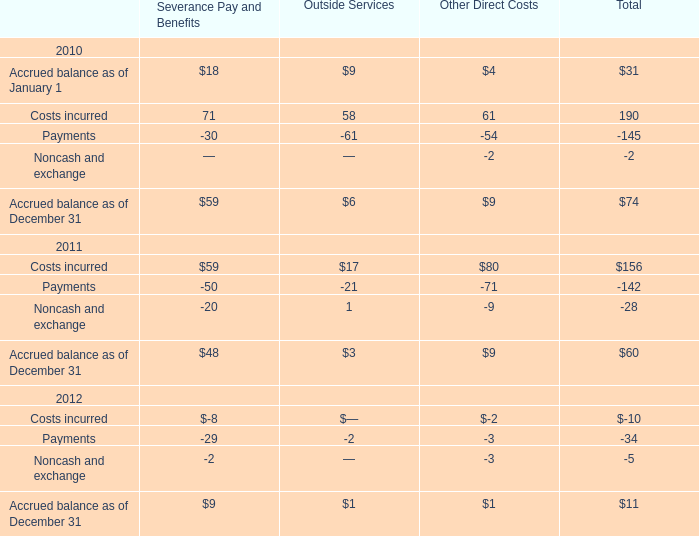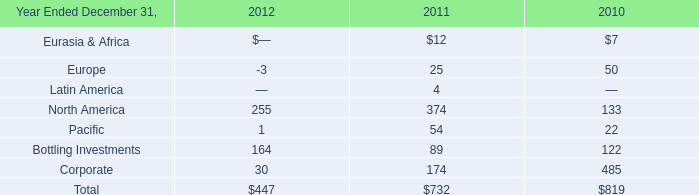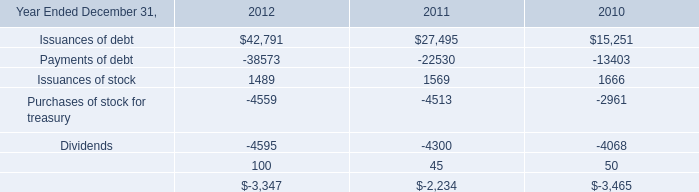In what year is Costs incurred for Total greater than 160? 
Answer: 2010. 